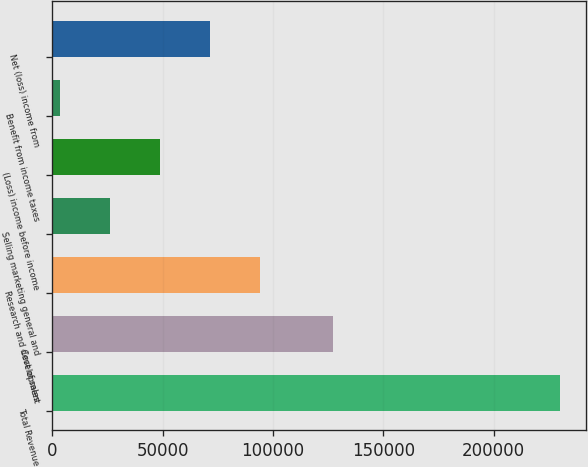<chart> <loc_0><loc_0><loc_500><loc_500><bar_chart><fcel>Total Revenue<fcel>Cost of sales<fcel>Research and development<fcel>Selling marketing general and<fcel>(Loss) income before income<fcel>Benefit from income taxes<fcel>Net (loss) income from<nl><fcel>230257<fcel>127283<fcel>94357<fcel>26407<fcel>49057<fcel>3757<fcel>71707<nl></chart> 